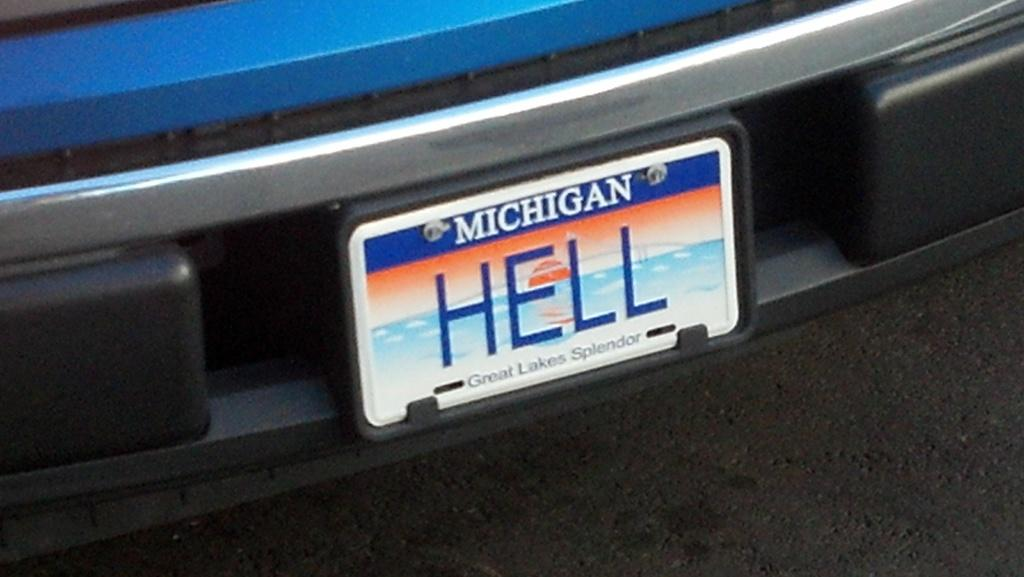<image>
Summarize the visual content of the image. A Michigan licence plate is customized to read Hell. 